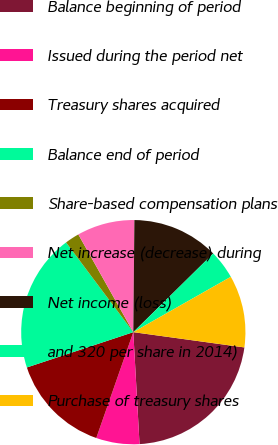Convert chart. <chart><loc_0><loc_0><loc_500><loc_500><pie_chart><fcel>(Dollars in thousands except<fcel>Balance beginning of period<fcel>Issued during the period net<fcel>Treasury shares acquired<fcel>Balance end of period<fcel>Share-based compensation plans<fcel>Net increase (decrease) during<fcel>Net income (loss)<fcel>and 320 per share in 2014)<fcel>Purchase of treasury shares<nl><fcel>0.0%<fcel>21.94%<fcel>6.24%<fcel>14.55%<fcel>19.86%<fcel>2.08%<fcel>8.31%<fcel>12.47%<fcel>4.16%<fcel>10.39%<nl></chart> 